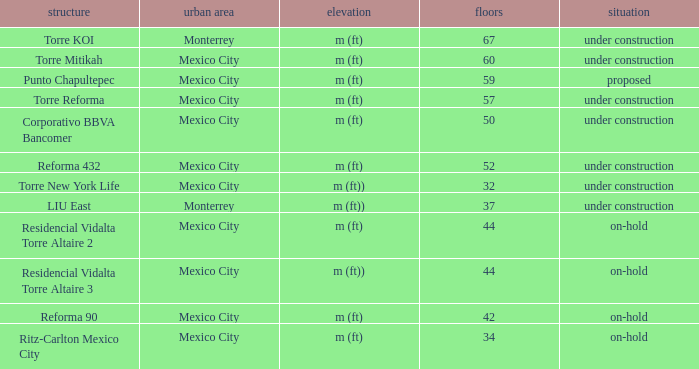How many stories is the torre reforma building? 1.0. 